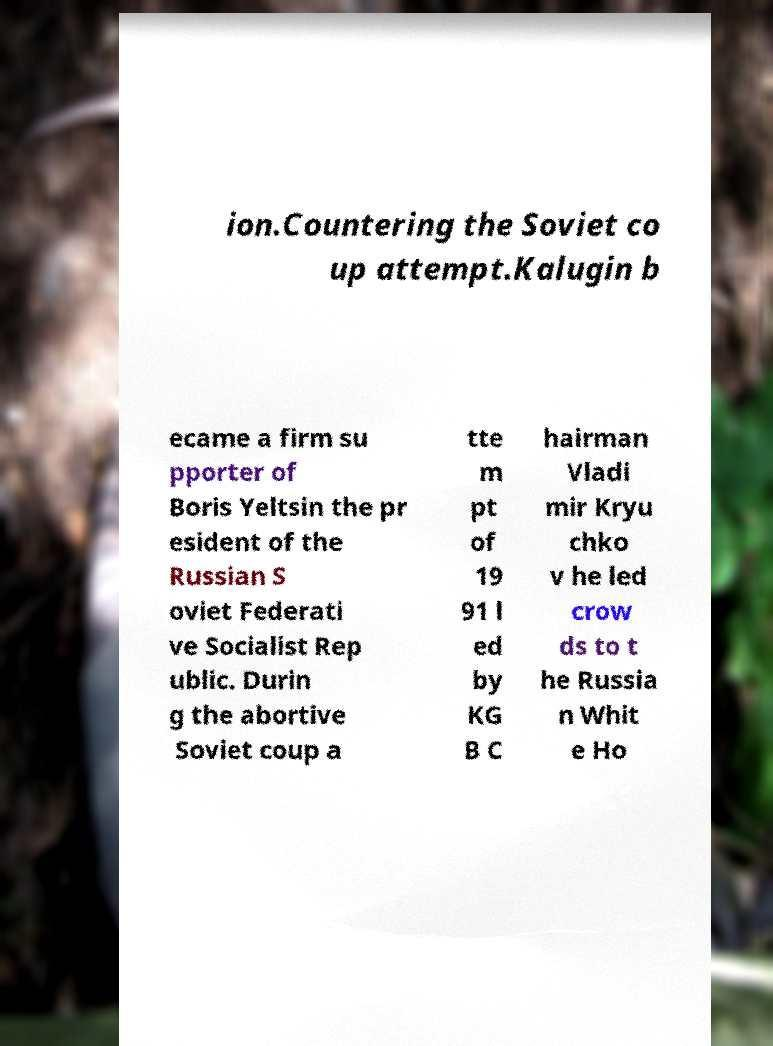What messages or text are displayed in this image? I need them in a readable, typed format. ion.Countering the Soviet co up attempt.Kalugin b ecame a firm su pporter of Boris Yeltsin the pr esident of the Russian S oviet Federati ve Socialist Rep ublic. Durin g the abortive Soviet coup a tte m pt of 19 91 l ed by KG B C hairman Vladi mir Kryu chko v he led crow ds to t he Russia n Whit e Ho 